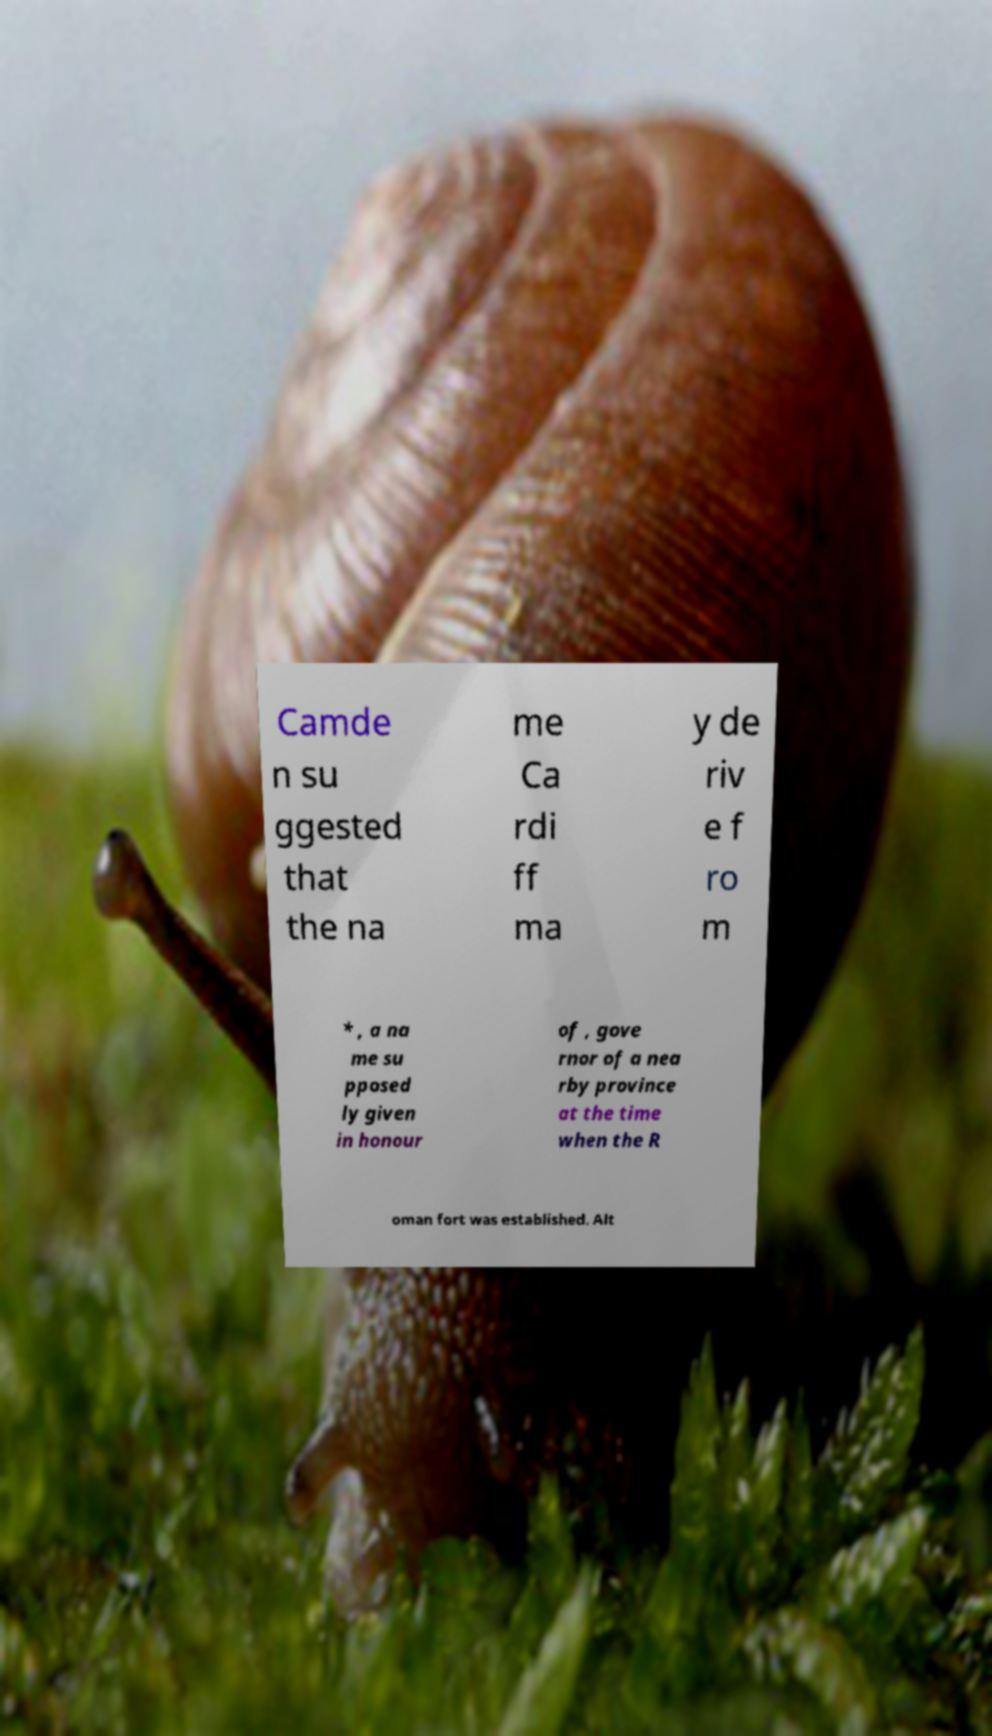Can you read and provide the text displayed in the image?This photo seems to have some interesting text. Can you extract and type it out for me? Camde n su ggested that the na me Ca rdi ff ma y de riv e f ro m * , a na me su pposed ly given in honour of , gove rnor of a nea rby province at the time when the R oman fort was established. Alt 